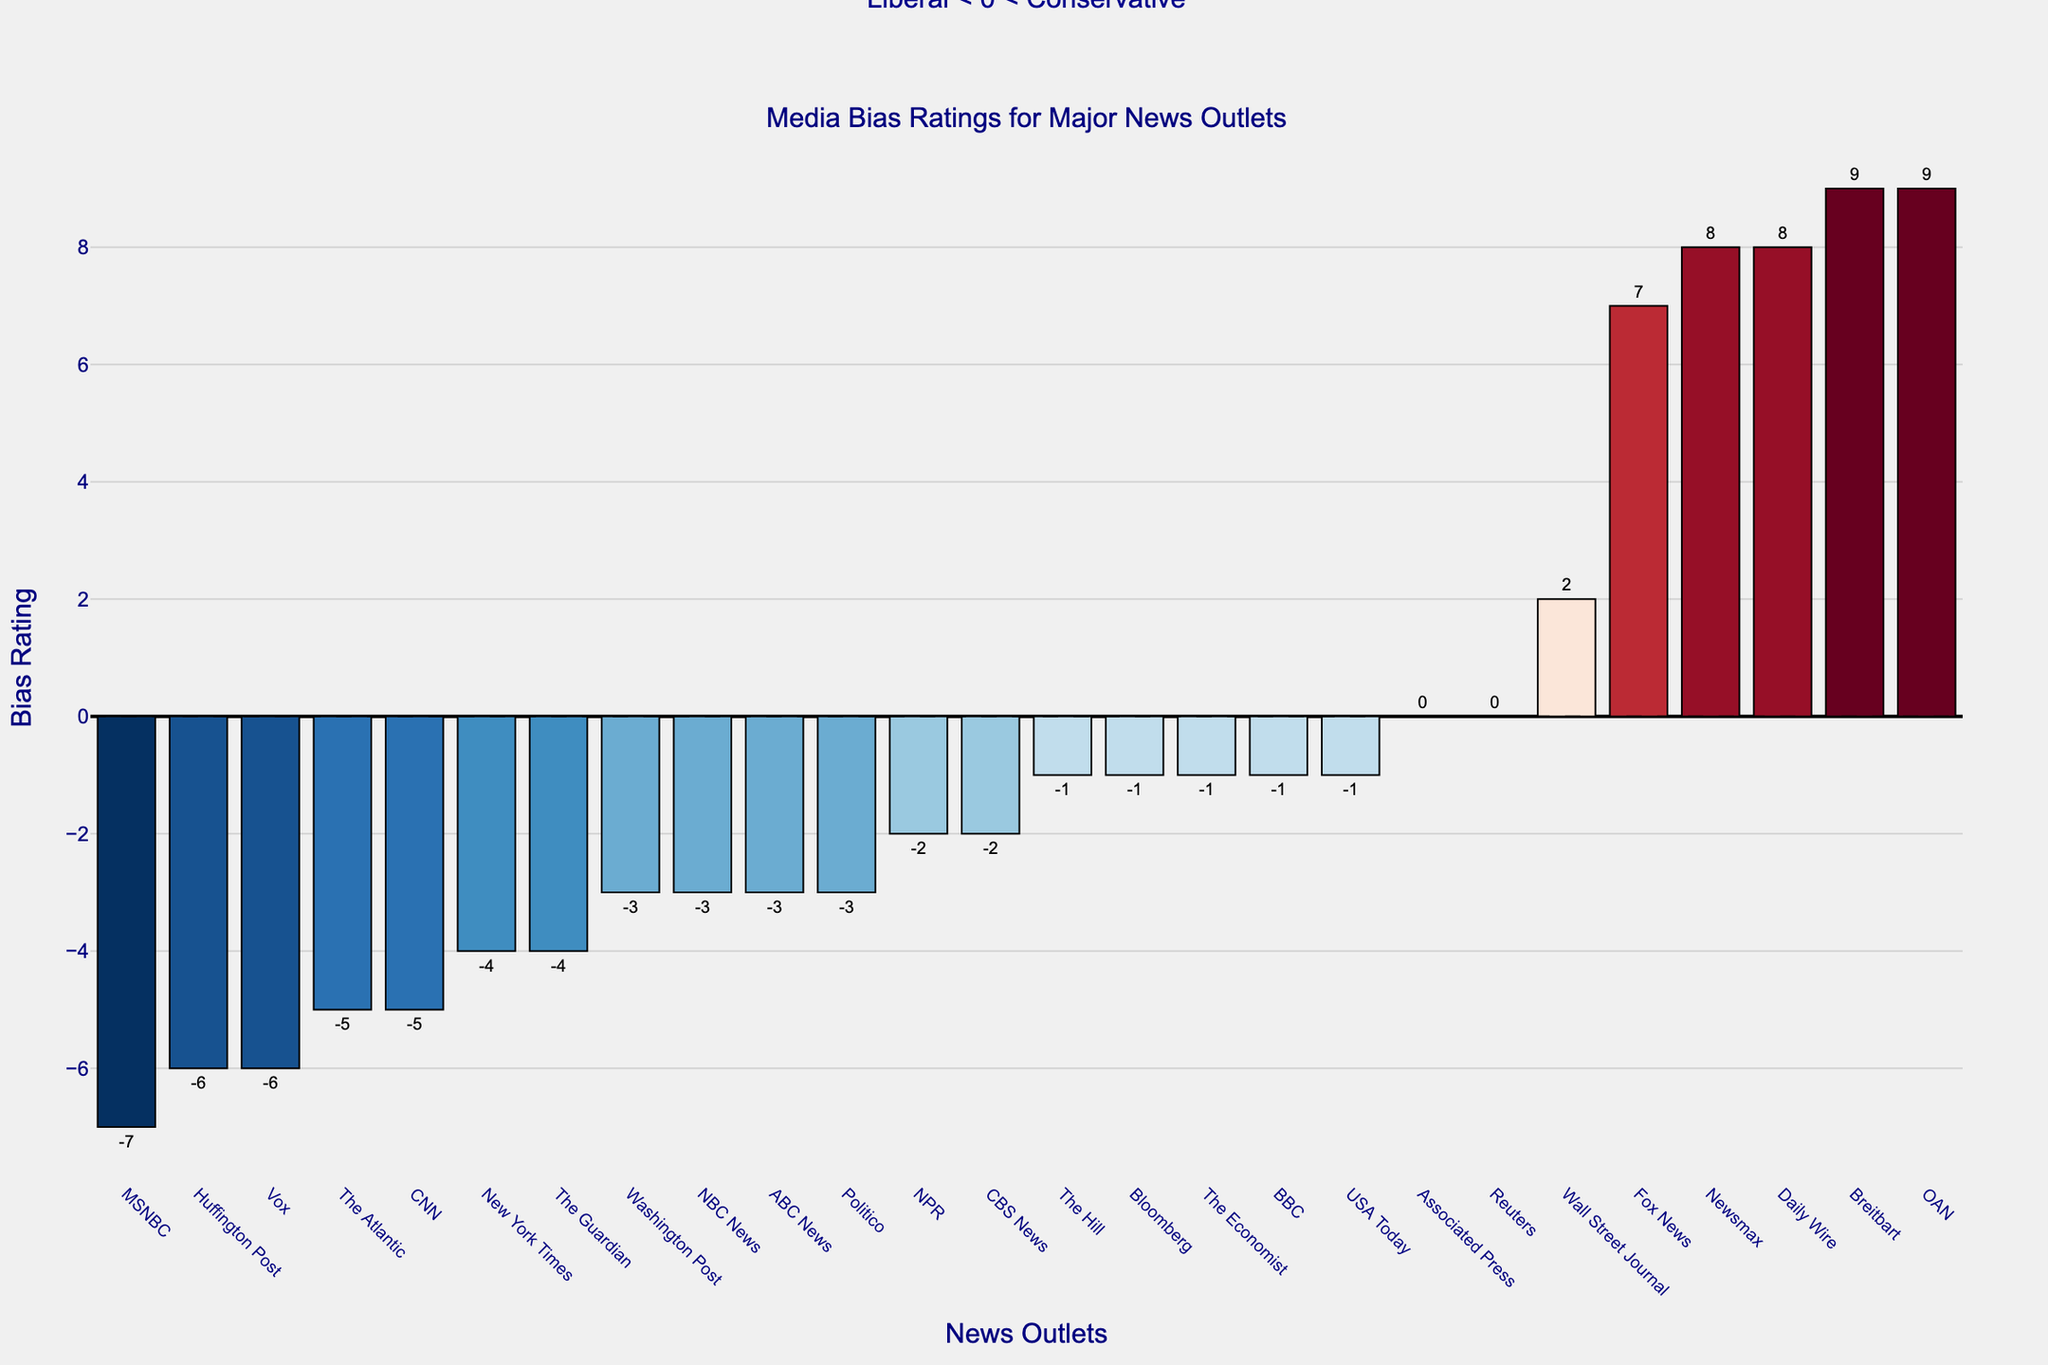Which news outlet is rated as the most conservative? By examining the height of the bars, the outlet with the highest bias rating is the most conservative. In this case, Breitbart has a bias rating of 9, making it the most conservative.
Answer: Breitbart Which news outlet has the most balanced (neutral) bias rating? By looking for the bar at the zero line, outlets with a bias rating of 0 are the most balanced. Both Reuters and the Associated Press have a bias rating of 0, indicating they are the most neutral.
Answer: Reuters, Associated Press How many news outlets have a bias rating that is considered liberal (less than 0)? By counting the bars with bias ratings less than 0, there are 13 outlets: NPR, BBC, New York Times, Washington Post, CNN, MSNBC, The Guardian, The Economist, USA Today, Politico, ABC News, CBS News, and NBC News.
Answer: 13 What’s the difference in bias ratings between Fox News and CNN? Fox News has a bias rating of 7, and CNN has a bias rating of -5. To find the difference, subtract CNN's rating from Fox News's rating: 7 - (-5) = 12.
Answer: 12 Are there more liberal or conservative news outlets? Count the number of bars with negative bias ratings for liberal and those with positive bias ratings for conservative. There are 13 liberal (negative) outlets and 8 conservative (positive) outlets.
Answer: More liberal Which outlet has a bias rating closest to the neutral point, but still lean conservative? By examining bars with positive ratings and selecting the smallest positive rating nearest to zero, the Wall Street Journal has a bias rating of 2, which is the closest conservative outlet to neutral.
Answer: Wall Street Journal Which news outlet has the second-most extreme bias rating, and what is that rating? After finding the most extreme bias rating (Breitbart with 9), locate the next highest or lowest rating. Daily Wire and Newsmax have the second-most extreme bias ratings of 8.
Answer: Daily Wire, Newsmax (8) What color appears on the bar representing The Guardian, and what does this indicate about its bias? The Guardian's bar is in a shade of blue, indicating a liberal bias as it lies below the zero line.
Answer: Blue, liberal Calculate the average bias rating of outlets considered conservative (greater than 0). Take the bias ratings of all conservative outlets: Wall Street Journal (2), Fox News (7), Daily Wire (8), Newsmax (8), and Breitbart (9). Sum (2 + 7 + 8 + 8 + 9 = 34), then divide by the number of outlets (34 / 5).
Answer: 6.8 Among the outlets with liberal (negative) bias ratings, which has the largest absolute value of bias, and what is it? Absolute values turn all negative numbers positive, so the largest absolute negative bias indicates the most extreme liberal bias. MSNBC has the lowest bias of -7.
Answer: MSNBC (7) 